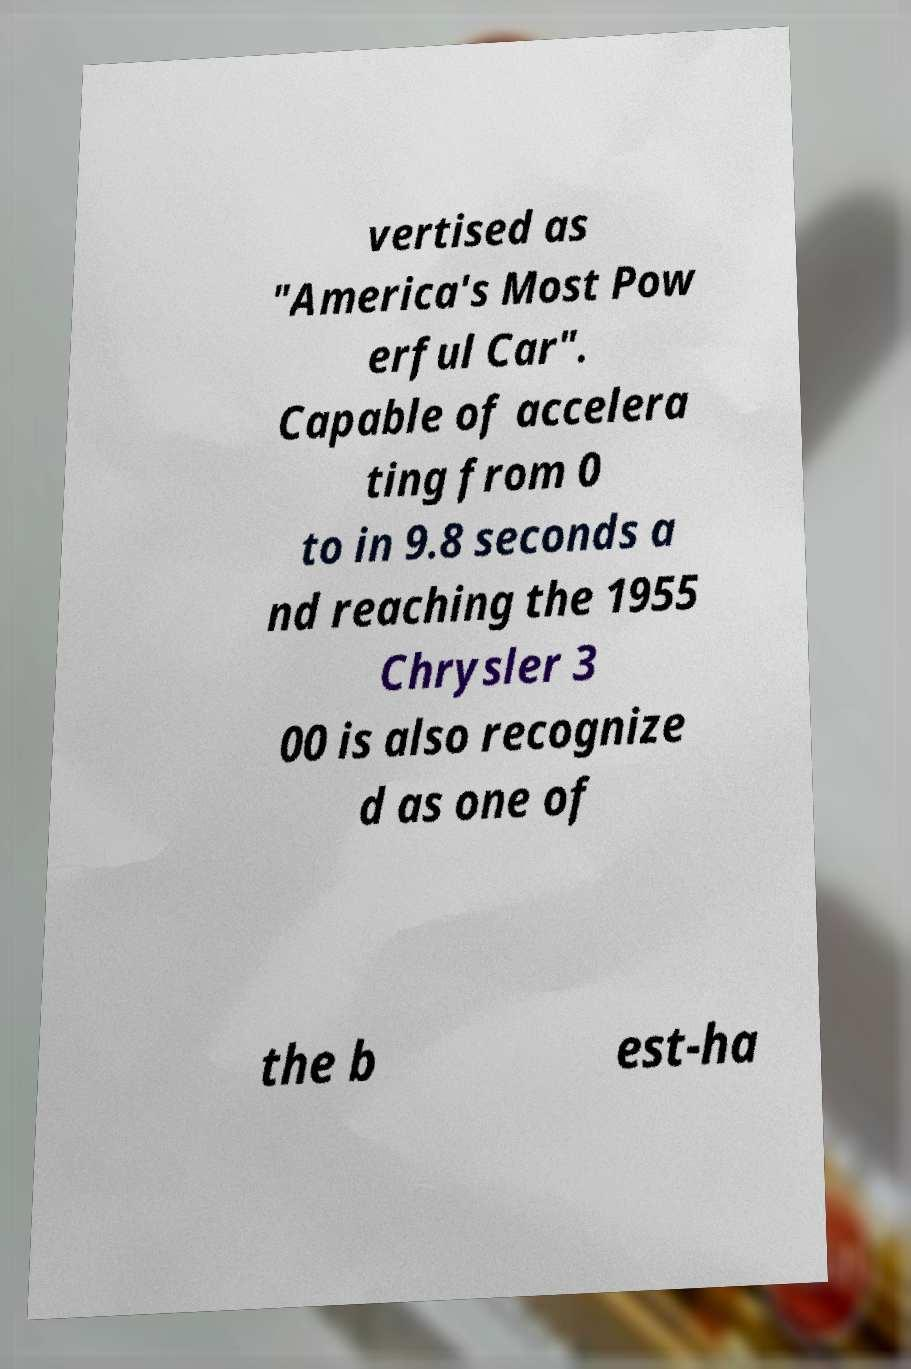Please read and relay the text visible in this image. What does it say? vertised as "America's Most Pow erful Car". Capable of accelera ting from 0 to in 9.8 seconds a nd reaching the 1955 Chrysler 3 00 is also recognize d as one of the b est-ha 